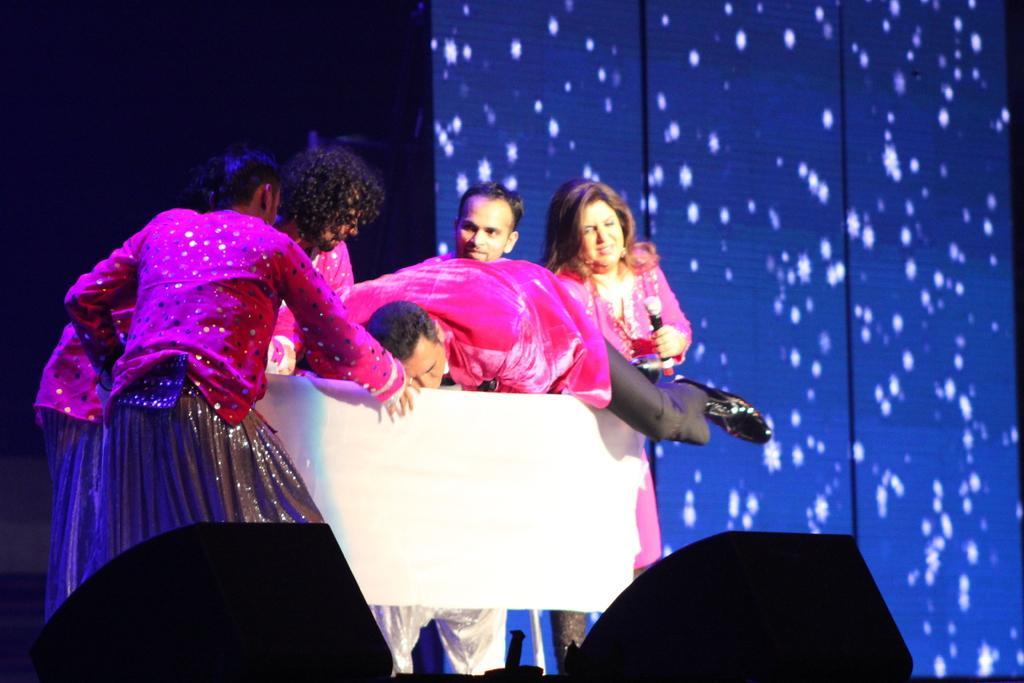In one or two sentences, can you explain what this image depicts? In this image we can see people in costumes, object look like wooden table and we can also see the blue background. 